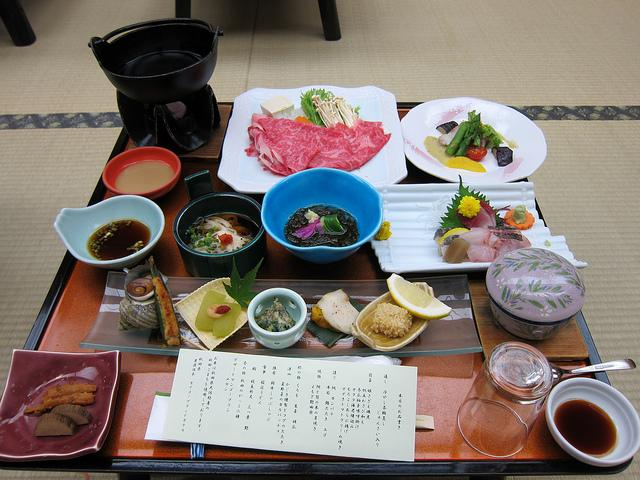Which food will add an acidic flavor to the food? Please explain your reasoning. lemon. Lemons add acid to the food making it sour. 